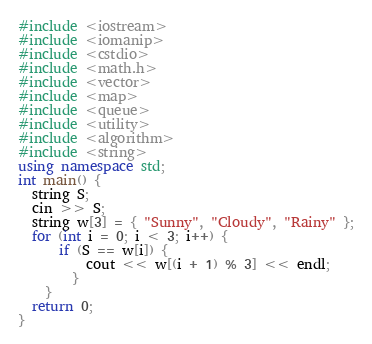<code> <loc_0><loc_0><loc_500><loc_500><_C++_>#include <iostream>
#include <iomanip>
#include <cstdio>
#include <math.h>
#include <vector>
#include <map>
#include <queue>
#include <utility>
#include <algorithm>
#include <string>
using namespace std;
int main() {
  string S;
  cin >> S;
  string w[3] = { "Sunny", "Cloudy", "Rainy" };
  for (int i = 0; i < 3; i++) {
	  if (S == w[i]) {
		  cout << w[(i + 1) % 3] << endl;
		}
	}
  return 0;
}
</code> 